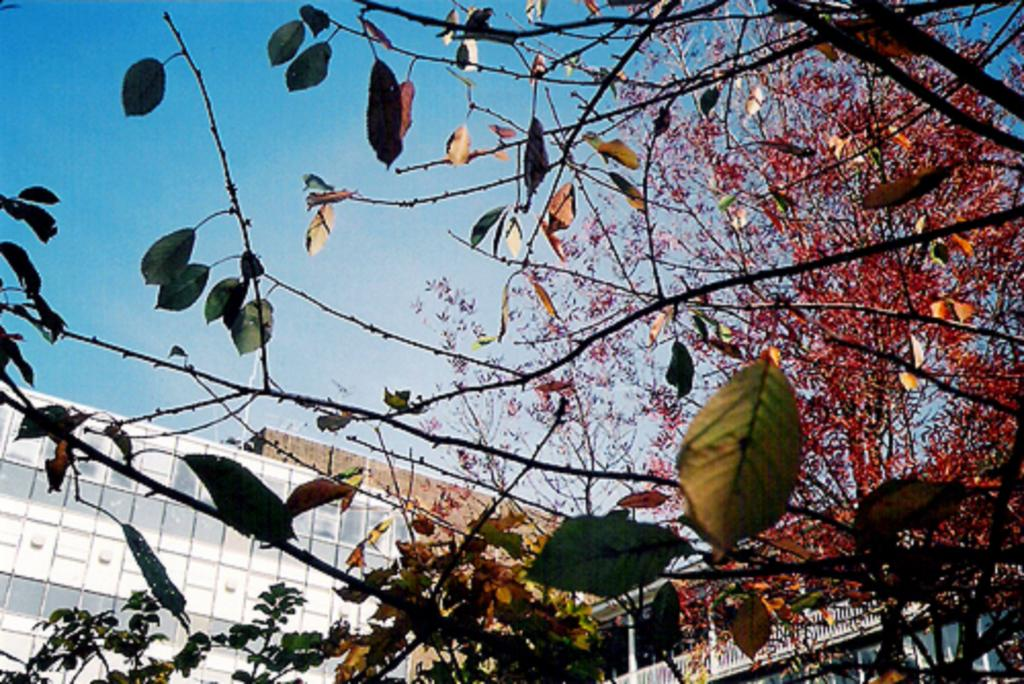Where was the picture taken? The picture was clicked outside. What can be seen on the right side of the image? There is a tree on the right side of the image. What is visible in the background of the image? There is a sky and buildings visible in the background of the image. What feature can be seen in the foreground of the image? There is a railing in the image. How many fingers can be seen on the shoe in the image? There is no shoe or fingers present in the image. 